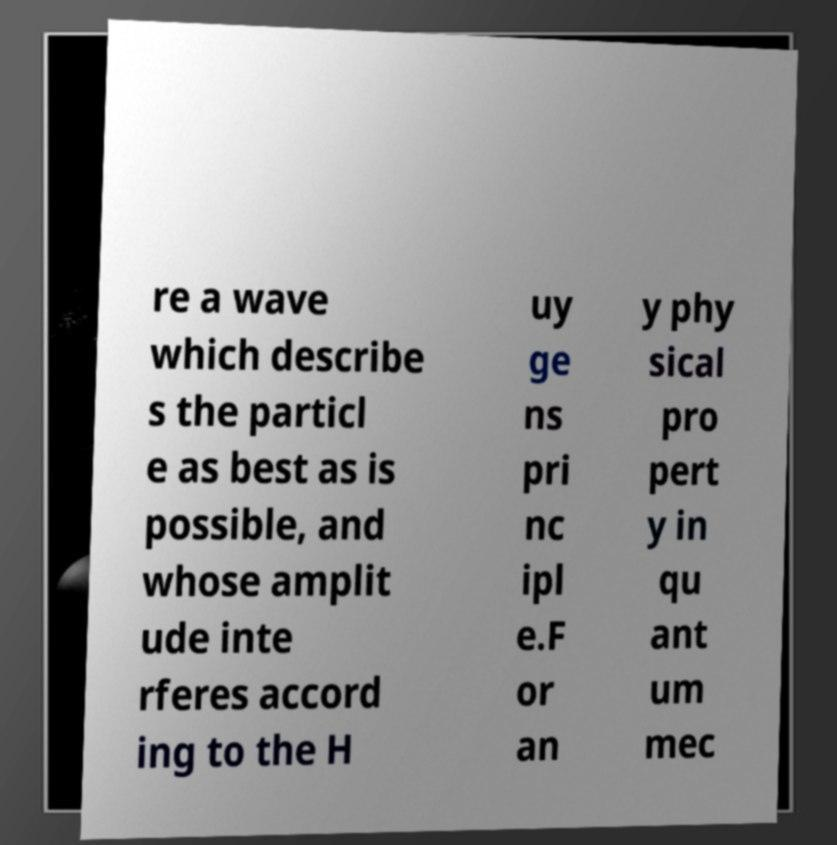Please identify and transcribe the text found in this image. re a wave which describe s the particl e as best as is possible, and whose amplit ude inte rferes accord ing to the H uy ge ns pri nc ipl e.F or an y phy sical pro pert y in qu ant um mec 